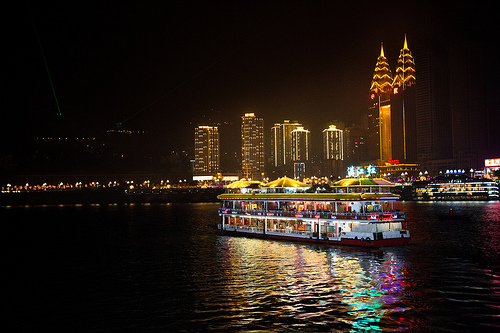Describe a futuristic version of this city. What changes do you envision? In a futuristic version of this city, the skyline would be dominated by even taller and more architecturally innovative buildings, possibly with sleek, curved designs and eco-friendly technologies like vertical gardens and energy-efficient facades. The boats on the water would be advanced hydrofoils or even floating leisure hubs, possibly powered by sustainable energy sources. The streets and waterways would be lined with holographic displays, guiding commuters and tourists alike with real-time information and vibrant advertising. Autonomous drones might deliver goods, while robotic assistants enhance the hospitality experience on the boats and at riverside venues. The overall atmosphere would blend the high-tech efficiency of future innovations with the timeless charm and social vibrancy of urban life. 